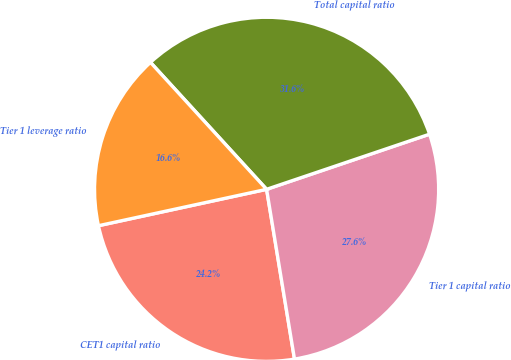Convert chart. <chart><loc_0><loc_0><loc_500><loc_500><pie_chart><fcel>CET1 capital ratio<fcel>Tier 1 capital ratio<fcel>Total capital ratio<fcel>Tier 1 leverage ratio<nl><fcel>24.2%<fcel>27.6%<fcel>31.6%<fcel>16.6%<nl></chart> 